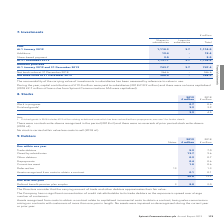According to Spirent Communications Plc's financial document, Why does the Company have no significant concentration of credit risk attributable to its trade debtors? as the exposure is spread over a large number of customers.. The document states: "n of credit risk attributable to its trade debtors as the exposure is spread over a large number of customers...." Also, What do the assets recognised from costs to obtain a contract relate to? capitalised incremental costs to obtain a contract, being sales commissions arising on contracts with customers of more than one year in length. The document states: "ognised from costs to obtain a contract relate to capitalised incremental costs to obtain a contract, being sales commissions arising on contracts wit..." Also, What are the components under Due within one year? The document contains multiple relevant values: Trade debtors, Owed by subsidiaries, Other debtors, Prepayments, Current tax asset, Deferred tax, Assets recognised from costs to obtain a contract. From the document: "Assets recognised from costs to obtain a contract 0.1 0.1 Owed by subsidiaries 13.7 9.6 Prepayments 0.4 0.6 Deferred tax 13 – 1.3 Other debtors 0.2 0...." Additionally, In which year was the amount due within one year larger? According to the financial document, 2019. The relevant text states: "179 Spirent Communications plc Annual Report 2019..." Also, can you calculate: What was the change in the amount owed by subsidiaries? Based on the calculation: 13.7-9.6, the result is 4.1 (in millions). This is based on the information: "Owed by subsidiaries 13.7 9.6 Owed by subsidiaries 13.7 9.6..." The key data points involved are: 13.7, 9.6. Also, can you calculate: What was the percentage change in the amount owed by subsidiaries? To answer this question, I need to perform calculations using the financial data. The calculation is: (13.7-9.6)/9.6, which equals 42.71 (percentage). This is based on the information: "Owed by subsidiaries 13.7 9.6 Owed by subsidiaries 13.7 9.6..." The key data points involved are: 13.7, 9.6. 